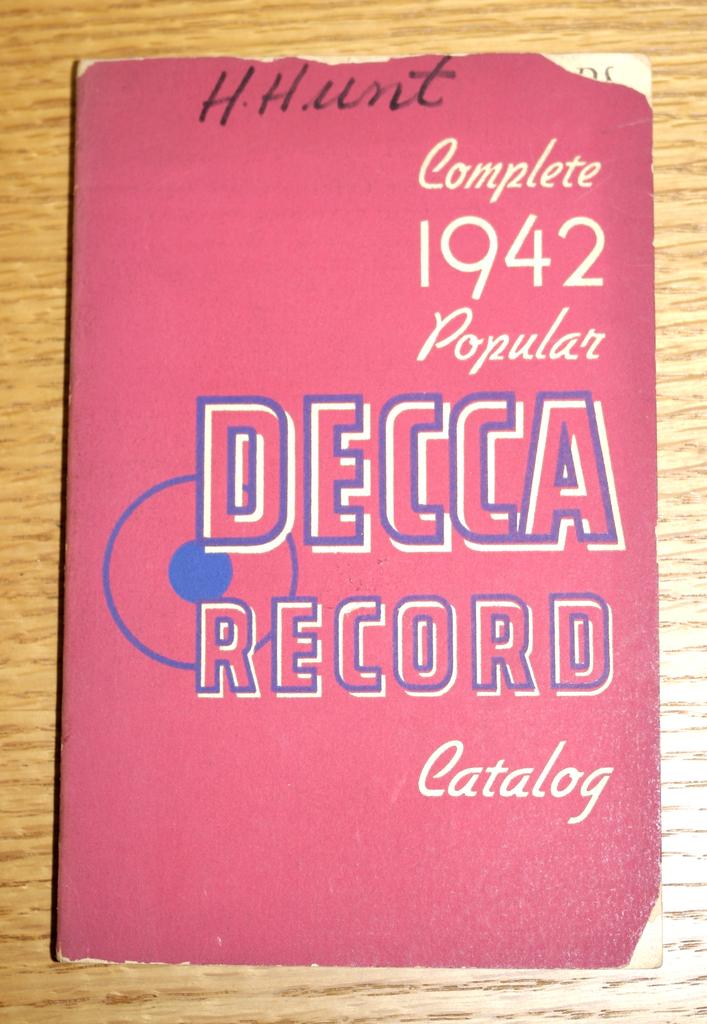What year is this?
Your answer should be compact. 1942. What name is written at the top of the cover?
Give a very brief answer. H. hunt. 